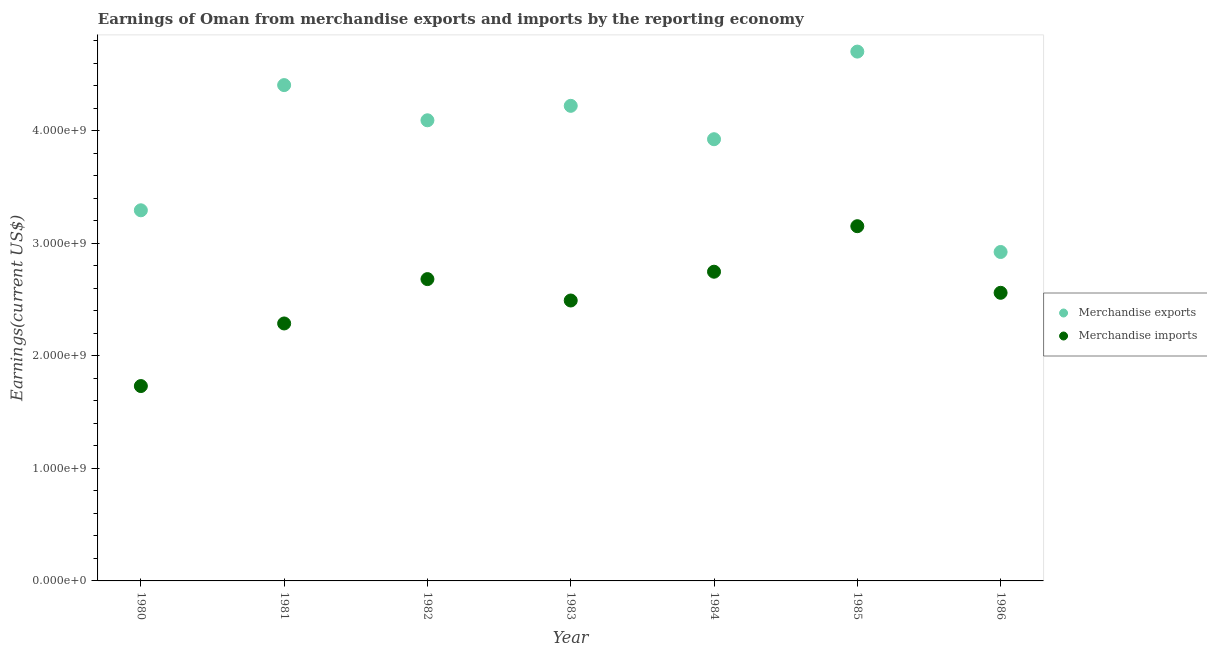How many different coloured dotlines are there?
Offer a terse response. 2. What is the earnings from merchandise exports in 1982?
Provide a short and direct response. 4.09e+09. Across all years, what is the maximum earnings from merchandise imports?
Your response must be concise. 3.15e+09. Across all years, what is the minimum earnings from merchandise exports?
Offer a terse response. 2.92e+09. In which year was the earnings from merchandise imports maximum?
Your answer should be compact. 1985. In which year was the earnings from merchandise exports minimum?
Offer a very short reply. 1986. What is the total earnings from merchandise imports in the graph?
Provide a short and direct response. 1.77e+1. What is the difference between the earnings from merchandise imports in 1980 and that in 1982?
Ensure brevity in your answer.  -9.51e+08. What is the difference between the earnings from merchandise imports in 1981 and the earnings from merchandise exports in 1980?
Provide a short and direct response. -1.01e+09. What is the average earnings from merchandise exports per year?
Provide a short and direct response. 3.94e+09. In the year 1980, what is the difference between the earnings from merchandise imports and earnings from merchandise exports?
Provide a short and direct response. -1.56e+09. What is the ratio of the earnings from merchandise exports in 1985 to that in 1986?
Offer a very short reply. 1.61. Is the earnings from merchandise exports in 1980 less than that in 1986?
Your response must be concise. No. Is the difference between the earnings from merchandise imports in 1981 and 1982 greater than the difference between the earnings from merchandise exports in 1981 and 1982?
Your answer should be compact. No. What is the difference between the highest and the second highest earnings from merchandise imports?
Keep it short and to the point. 4.05e+08. What is the difference between the highest and the lowest earnings from merchandise exports?
Offer a terse response. 1.78e+09. Is the sum of the earnings from merchandise imports in 1985 and 1986 greater than the maximum earnings from merchandise exports across all years?
Your response must be concise. Yes. Is the earnings from merchandise imports strictly less than the earnings from merchandise exports over the years?
Provide a succinct answer. Yes. How many dotlines are there?
Your answer should be compact. 2. How many years are there in the graph?
Your answer should be very brief. 7. Where does the legend appear in the graph?
Provide a succinct answer. Center right. What is the title of the graph?
Offer a terse response. Earnings of Oman from merchandise exports and imports by the reporting economy. Does "Crop" appear as one of the legend labels in the graph?
Offer a terse response. No. What is the label or title of the X-axis?
Keep it short and to the point. Year. What is the label or title of the Y-axis?
Offer a terse response. Earnings(current US$). What is the Earnings(current US$) in Merchandise exports in 1980?
Keep it short and to the point. 3.29e+09. What is the Earnings(current US$) in Merchandise imports in 1980?
Provide a succinct answer. 1.73e+09. What is the Earnings(current US$) of Merchandise exports in 1981?
Offer a very short reply. 4.41e+09. What is the Earnings(current US$) of Merchandise imports in 1981?
Give a very brief answer. 2.29e+09. What is the Earnings(current US$) in Merchandise exports in 1982?
Ensure brevity in your answer.  4.09e+09. What is the Earnings(current US$) in Merchandise imports in 1982?
Provide a succinct answer. 2.68e+09. What is the Earnings(current US$) of Merchandise exports in 1983?
Your answer should be very brief. 4.22e+09. What is the Earnings(current US$) in Merchandise imports in 1983?
Keep it short and to the point. 2.49e+09. What is the Earnings(current US$) of Merchandise exports in 1984?
Give a very brief answer. 3.93e+09. What is the Earnings(current US$) of Merchandise imports in 1984?
Offer a very short reply. 2.75e+09. What is the Earnings(current US$) of Merchandise exports in 1985?
Your answer should be very brief. 4.70e+09. What is the Earnings(current US$) in Merchandise imports in 1985?
Your answer should be compact. 3.15e+09. What is the Earnings(current US$) in Merchandise exports in 1986?
Keep it short and to the point. 2.92e+09. What is the Earnings(current US$) of Merchandise imports in 1986?
Make the answer very short. 2.56e+09. Across all years, what is the maximum Earnings(current US$) in Merchandise exports?
Offer a very short reply. 4.70e+09. Across all years, what is the maximum Earnings(current US$) in Merchandise imports?
Your response must be concise. 3.15e+09. Across all years, what is the minimum Earnings(current US$) of Merchandise exports?
Keep it short and to the point. 2.92e+09. Across all years, what is the minimum Earnings(current US$) in Merchandise imports?
Provide a short and direct response. 1.73e+09. What is the total Earnings(current US$) in Merchandise exports in the graph?
Your answer should be compact. 2.76e+1. What is the total Earnings(current US$) of Merchandise imports in the graph?
Offer a terse response. 1.77e+1. What is the difference between the Earnings(current US$) in Merchandise exports in 1980 and that in 1981?
Your response must be concise. -1.11e+09. What is the difference between the Earnings(current US$) in Merchandise imports in 1980 and that in 1981?
Keep it short and to the point. -5.56e+08. What is the difference between the Earnings(current US$) in Merchandise exports in 1980 and that in 1982?
Offer a terse response. -8.00e+08. What is the difference between the Earnings(current US$) of Merchandise imports in 1980 and that in 1982?
Give a very brief answer. -9.51e+08. What is the difference between the Earnings(current US$) of Merchandise exports in 1980 and that in 1983?
Your answer should be very brief. -9.28e+08. What is the difference between the Earnings(current US$) in Merchandise imports in 1980 and that in 1983?
Offer a very short reply. -7.60e+08. What is the difference between the Earnings(current US$) in Merchandise exports in 1980 and that in 1984?
Your response must be concise. -6.32e+08. What is the difference between the Earnings(current US$) of Merchandise imports in 1980 and that in 1984?
Offer a very short reply. -1.02e+09. What is the difference between the Earnings(current US$) in Merchandise exports in 1980 and that in 1985?
Give a very brief answer. -1.41e+09. What is the difference between the Earnings(current US$) of Merchandise imports in 1980 and that in 1985?
Make the answer very short. -1.42e+09. What is the difference between the Earnings(current US$) of Merchandise exports in 1980 and that in 1986?
Provide a succinct answer. 3.71e+08. What is the difference between the Earnings(current US$) of Merchandise imports in 1980 and that in 1986?
Give a very brief answer. -8.29e+08. What is the difference between the Earnings(current US$) in Merchandise exports in 1981 and that in 1982?
Your response must be concise. 3.13e+08. What is the difference between the Earnings(current US$) of Merchandise imports in 1981 and that in 1982?
Provide a short and direct response. -3.94e+08. What is the difference between the Earnings(current US$) of Merchandise exports in 1981 and that in 1983?
Provide a succinct answer. 1.84e+08. What is the difference between the Earnings(current US$) of Merchandise imports in 1981 and that in 1983?
Your answer should be compact. -2.04e+08. What is the difference between the Earnings(current US$) of Merchandise exports in 1981 and that in 1984?
Offer a very short reply. 4.81e+08. What is the difference between the Earnings(current US$) in Merchandise imports in 1981 and that in 1984?
Your response must be concise. -4.60e+08. What is the difference between the Earnings(current US$) of Merchandise exports in 1981 and that in 1985?
Make the answer very short. -2.98e+08. What is the difference between the Earnings(current US$) of Merchandise imports in 1981 and that in 1985?
Your answer should be compact. -8.65e+08. What is the difference between the Earnings(current US$) in Merchandise exports in 1981 and that in 1986?
Make the answer very short. 1.48e+09. What is the difference between the Earnings(current US$) in Merchandise imports in 1981 and that in 1986?
Keep it short and to the point. -2.73e+08. What is the difference between the Earnings(current US$) of Merchandise exports in 1982 and that in 1983?
Keep it short and to the point. -1.28e+08. What is the difference between the Earnings(current US$) in Merchandise imports in 1982 and that in 1983?
Provide a short and direct response. 1.90e+08. What is the difference between the Earnings(current US$) of Merchandise exports in 1982 and that in 1984?
Provide a succinct answer. 1.68e+08. What is the difference between the Earnings(current US$) of Merchandise imports in 1982 and that in 1984?
Your answer should be very brief. -6.56e+07. What is the difference between the Earnings(current US$) of Merchandise exports in 1982 and that in 1985?
Your answer should be compact. -6.11e+08. What is the difference between the Earnings(current US$) in Merchandise imports in 1982 and that in 1985?
Offer a very short reply. -4.70e+08. What is the difference between the Earnings(current US$) in Merchandise exports in 1982 and that in 1986?
Provide a short and direct response. 1.17e+09. What is the difference between the Earnings(current US$) in Merchandise imports in 1982 and that in 1986?
Give a very brief answer. 1.22e+08. What is the difference between the Earnings(current US$) of Merchandise exports in 1983 and that in 1984?
Ensure brevity in your answer.  2.97e+08. What is the difference between the Earnings(current US$) of Merchandise imports in 1983 and that in 1984?
Your answer should be very brief. -2.56e+08. What is the difference between the Earnings(current US$) in Merchandise exports in 1983 and that in 1985?
Your answer should be compact. -4.82e+08. What is the difference between the Earnings(current US$) of Merchandise imports in 1983 and that in 1985?
Offer a terse response. -6.60e+08. What is the difference between the Earnings(current US$) in Merchandise exports in 1983 and that in 1986?
Give a very brief answer. 1.30e+09. What is the difference between the Earnings(current US$) of Merchandise imports in 1983 and that in 1986?
Offer a very short reply. -6.85e+07. What is the difference between the Earnings(current US$) in Merchandise exports in 1984 and that in 1985?
Provide a succinct answer. -7.79e+08. What is the difference between the Earnings(current US$) of Merchandise imports in 1984 and that in 1985?
Ensure brevity in your answer.  -4.05e+08. What is the difference between the Earnings(current US$) in Merchandise exports in 1984 and that in 1986?
Your response must be concise. 1.00e+09. What is the difference between the Earnings(current US$) of Merchandise imports in 1984 and that in 1986?
Ensure brevity in your answer.  1.87e+08. What is the difference between the Earnings(current US$) in Merchandise exports in 1985 and that in 1986?
Your answer should be very brief. 1.78e+09. What is the difference between the Earnings(current US$) of Merchandise imports in 1985 and that in 1986?
Provide a succinct answer. 5.92e+08. What is the difference between the Earnings(current US$) of Merchandise exports in 1980 and the Earnings(current US$) of Merchandise imports in 1981?
Offer a terse response. 1.01e+09. What is the difference between the Earnings(current US$) of Merchandise exports in 1980 and the Earnings(current US$) of Merchandise imports in 1982?
Give a very brief answer. 6.12e+08. What is the difference between the Earnings(current US$) in Merchandise exports in 1980 and the Earnings(current US$) in Merchandise imports in 1983?
Offer a terse response. 8.02e+08. What is the difference between the Earnings(current US$) in Merchandise exports in 1980 and the Earnings(current US$) in Merchandise imports in 1984?
Give a very brief answer. 5.46e+08. What is the difference between the Earnings(current US$) of Merchandise exports in 1980 and the Earnings(current US$) of Merchandise imports in 1985?
Your answer should be compact. 1.41e+08. What is the difference between the Earnings(current US$) of Merchandise exports in 1980 and the Earnings(current US$) of Merchandise imports in 1986?
Provide a short and direct response. 7.33e+08. What is the difference between the Earnings(current US$) of Merchandise exports in 1981 and the Earnings(current US$) of Merchandise imports in 1982?
Provide a succinct answer. 1.72e+09. What is the difference between the Earnings(current US$) in Merchandise exports in 1981 and the Earnings(current US$) in Merchandise imports in 1983?
Make the answer very short. 1.91e+09. What is the difference between the Earnings(current US$) in Merchandise exports in 1981 and the Earnings(current US$) in Merchandise imports in 1984?
Ensure brevity in your answer.  1.66e+09. What is the difference between the Earnings(current US$) of Merchandise exports in 1981 and the Earnings(current US$) of Merchandise imports in 1985?
Ensure brevity in your answer.  1.25e+09. What is the difference between the Earnings(current US$) in Merchandise exports in 1981 and the Earnings(current US$) in Merchandise imports in 1986?
Your response must be concise. 1.85e+09. What is the difference between the Earnings(current US$) of Merchandise exports in 1982 and the Earnings(current US$) of Merchandise imports in 1983?
Keep it short and to the point. 1.60e+09. What is the difference between the Earnings(current US$) of Merchandise exports in 1982 and the Earnings(current US$) of Merchandise imports in 1984?
Give a very brief answer. 1.35e+09. What is the difference between the Earnings(current US$) in Merchandise exports in 1982 and the Earnings(current US$) in Merchandise imports in 1985?
Keep it short and to the point. 9.41e+08. What is the difference between the Earnings(current US$) of Merchandise exports in 1982 and the Earnings(current US$) of Merchandise imports in 1986?
Provide a succinct answer. 1.53e+09. What is the difference between the Earnings(current US$) in Merchandise exports in 1983 and the Earnings(current US$) in Merchandise imports in 1984?
Offer a very short reply. 1.47e+09. What is the difference between the Earnings(current US$) of Merchandise exports in 1983 and the Earnings(current US$) of Merchandise imports in 1985?
Offer a terse response. 1.07e+09. What is the difference between the Earnings(current US$) of Merchandise exports in 1983 and the Earnings(current US$) of Merchandise imports in 1986?
Keep it short and to the point. 1.66e+09. What is the difference between the Earnings(current US$) of Merchandise exports in 1984 and the Earnings(current US$) of Merchandise imports in 1985?
Give a very brief answer. 7.73e+08. What is the difference between the Earnings(current US$) in Merchandise exports in 1984 and the Earnings(current US$) in Merchandise imports in 1986?
Give a very brief answer. 1.36e+09. What is the difference between the Earnings(current US$) in Merchandise exports in 1985 and the Earnings(current US$) in Merchandise imports in 1986?
Provide a succinct answer. 2.14e+09. What is the average Earnings(current US$) of Merchandise exports per year?
Your response must be concise. 3.94e+09. What is the average Earnings(current US$) of Merchandise imports per year?
Ensure brevity in your answer.  2.52e+09. In the year 1980, what is the difference between the Earnings(current US$) of Merchandise exports and Earnings(current US$) of Merchandise imports?
Offer a very short reply. 1.56e+09. In the year 1981, what is the difference between the Earnings(current US$) in Merchandise exports and Earnings(current US$) in Merchandise imports?
Provide a succinct answer. 2.12e+09. In the year 1982, what is the difference between the Earnings(current US$) in Merchandise exports and Earnings(current US$) in Merchandise imports?
Offer a very short reply. 1.41e+09. In the year 1983, what is the difference between the Earnings(current US$) in Merchandise exports and Earnings(current US$) in Merchandise imports?
Keep it short and to the point. 1.73e+09. In the year 1984, what is the difference between the Earnings(current US$) of Merchandise exports and Earnings(current US$) of Merchandise imports?
Offer a terse response. 1.18e+09. In the year 1985, what is the difference between the Earnings(current US$) of Merchandise exports and Earnings(current US$) of Merchandise imports?
Ensure brevity in your answer.  1.55e+09. In the year 1986, what is the difference between the Earnings(current US$) in Merchandise exports and Earnings(current US$) in Merchandise imports?
Your answer should be very brief. 3.63e+08. What is the ratio of the Earnings(current US$) of Merchandise exports in 1980 to that in 1981?
Offer a terse response. 0.75. What is the ratio of the Earnings(current US$) in Merchandise imports in 1980 to that in 1981?
Make the answer very short. 0.76. What is the ratio of the Earnings(current US$) in Merchandise exports in 1980 to that in 1982?
Provide a short and direct response. 0.8. What is the ratio of the Earnings(current US$) of Merchandise imports in 1980 to that in 1982?
Give a very brief answer. 0.65. What is the ratio of the Earnings(current US$) of Merchandise exports in 1980 to that in 1983?
Provide a short and direct response. 0.78. What is the ratio of the Earnings(current US$) in Merchandise imports in 1980 to that in 1983?
Provide a short and direct response. 0.69. What is the ratio of the Earnings(current US$) in Merchandise exports in 1980 to that in 1984?
Make the answer very short. 0.84. What is the ratio of the Earnings(current US$) in Merchandise imports in 1980 to that in 1984?
Keep it short and to the point. 0.63. What is the ratio of the Earnings(current US$) of Merchandise exports in 1980 to that in 1985?
Keep it short and to the point. 0.7. What is the ratio of the Earnings(current US$) of Merchandise imports in 1980 to that in 1985?
Offer a very short reply. 0.55. What is the ratio of the Earnings(current US$) of Merchandise exports in 1980 to that in 1986?
Offer a terse response. 1.13. What is the ratio of the Earnings(current US$) in Merchandise imports in 1980 to that in 1986?
Ensure brevity in your answer.  0.68. What is the ratio of the Earnings(current US$) of Merchandise exports in 1981 to that in 1982?
Ensure brevity in your answer.  1.08. What is the ratio of the Earnings(current US$) in Merchandise imports in 1981 to that in 1982?
Offer a very short reply. 0.85. What is the ratio of the Earnings(current US$) of Merchandise exports in 1981 to that in 1983?
Your response must be concise. 1.04. What is the ratio of the Earnings(current US$) of Merchandise imports in 1981 to that in 1983?
Provide a succinct answer. 0.92. What is the ratio of the Earnings(current US$) of Merchandise exports in 1981 to that in 1984?
Your answer should be very brief. 1.12. What is the ratio of the Earnings(current US$) of Merchandise imports in 1981 to that in 1984?
Make the answer very short. 0.83. What is the ratio of the Earnings(current US$) in Merchandise exports in 1981 to that in 1985?
Provide a succinct answer. 0.94. What is the ratio of the Earnings(current US$) of Merchandise imports in 1981 to that in 1985?
Your answer should be compact. 0.73. What is the ratio of the Earnings(current US$) of Merchandise exports in 1981 to that in 1986?
Provide a short and direct response. 1.51. What is the ratio of the Earnings(current US$) of Merchandise imports in 1981 to that in 1986?
Provide a short and direct response. 0.89. What is the ratio of the Earnings(current US$) in Merchandise exports in 1982 to that in 1983?
Your response must be concise. 0.97. What is the ratio of the Earnings(current US$) in Merchandise imports in 1982 to that in 1983?
Provide a short and direct response. 1.08. What is the ratio of the Earnings(current US$) in Merchandise exports in 1982 to that in 1984?
Offer a very short reply. 1.04. What is the ratio of the Earnings(current US$) in Merchandise imports in 1982 to that in 1984?
Make the answer very short. 0.98. What is the ratio of the Earnings(current US$) of Merchandise exports in 1982 to that in 1985?
Keep it short and to the point. 0.87. What is the ratio of the Earnings(current US$) in Merchandise imports in 1982 to that in 1985?
Offer a very short reply. 0.85. What is the ratio of the Earnings(current US$) of Merchandise exports in 1982 to that in 1986?
Keep it short and to the point. 1.4. What is the ratio of the Earnings(current US$) in Merchandise imports in 1982 to that in 1986?
Give a very brief answer. 1.05. What is the ratio of the Earnings(current US$) in Merchandise exports in 1983 to that in 1984?
Give a very brief answer. 1.08. What is the ratio of the Earnings(current US$) in Merchandise imports in 1983 to that in 1984?
Offer a very short reply. 0.91. What is the ratio of the Earnings(current US$) of Merchandise exports in 1983 to that in 1985?
Your response must be concise. 0.9. What is the ratio of the Earnings(current US$) in Merchandise imports in 1983 to that in 1985?
Your answer should be very brief. 0.79. What is the ratio of the Earnings(current US$) of Merchandise exports in 1983 to that in 1986?
Your answer should be very brief. 1.44. What is the ratio of the Earnings(current US$) in Merchandise imports in 1983 to that in 1986?
Make the answer very short. 0.97. What is the ratio of the Earnings(current US$) in Merchandise exports in 1984 to that in 1985?
Provide a short and direct response. 0.83. What is the ratio of the Earnings(current US$) in Merchandise imports in 1984 to that in 1985?
Your answer should be very brief. 0.87. What is the ratio of the Earnings(current US$) in Merchandise exports in 1984 to that in 1986?
Offer a very short reply. 1.34. What is the ratio of the Earnings(current US$) in Merchandise imports in 1984 to that in 1986?
Your answer should be very brief. 1.07. What is the ratio of the Earnings(current US$) of Merchandise exports in 1985 to that in 1986?
Keep it short and to the point. 1.61. What is the ratio of the Earnings(current US$) of Merchandise imports in 1985 to that in 1986?
Ensure brevity in your answer.  1.23. What is the difference between the highest and the second highest Earnings(current US$) of Merchandise exports?
Give a very brief answer. 2.98e+08. What is the difference between the highest and the second highest Earnings(current US$) in Merchandise imports?
Offer a terse response. 4.05e+08. What is the difference between the highest and the lowest Earnings(current US$) in Merchandise exports?
Give a very brief answer. 1.78e+09. What is the difference between the highest and the lowest Earnings(current US$) of Merchandise imports?
Your answer should be very brief. 1.42e+09. 